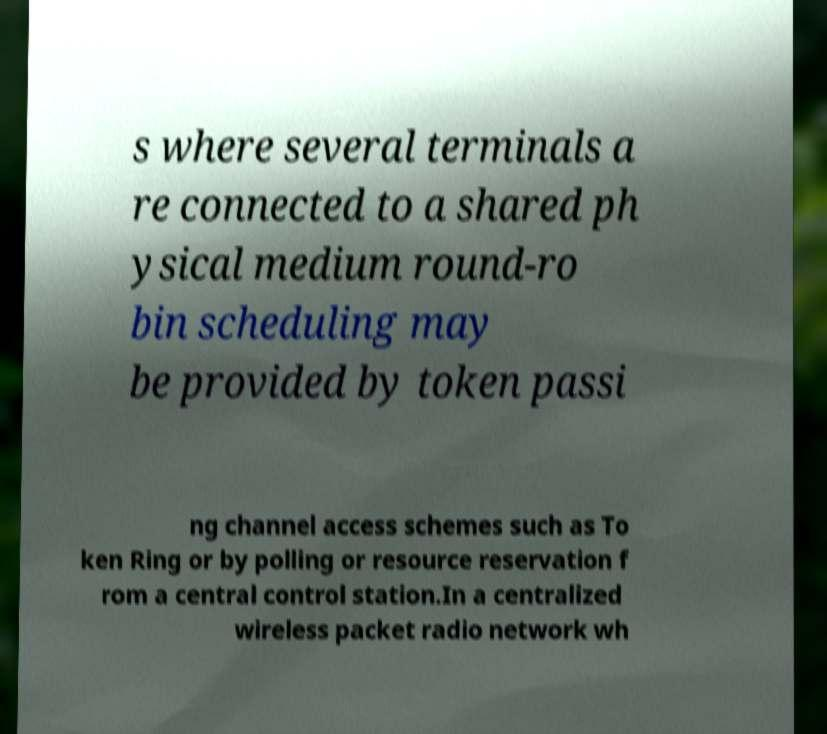Could you extract and type out the text from this image? s where several terminals a re connected to a shared ph ysical medium round-ro bin scheduling may be provided by token passi ng channel access schemes such as To ken Ring or by polling or resource reservation f rom a central control station.In a centralized wireless packet radio network wh 